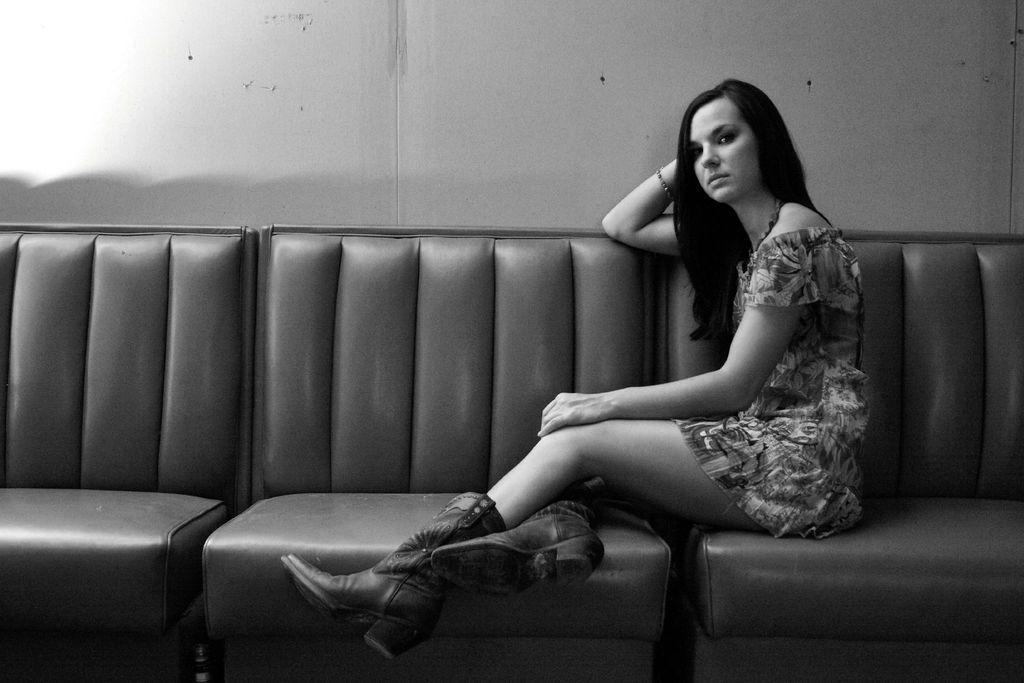Who is the main subject in the image? There is a woman in the image. What is the woman doing in the image? The woman is sitting on a couch. What is the woman wearing in the image? The woman is wearing a dress and shoes with heels. What is the appearance of the woman's hair in the image? The woman has long hair. What accessory is the woman wearing on her hand in the image? The woman has a hand band on her hand. What type of pin can be seen holding the knowledge bulb in the image? There is no pin or knowledge bulb present in the image. 